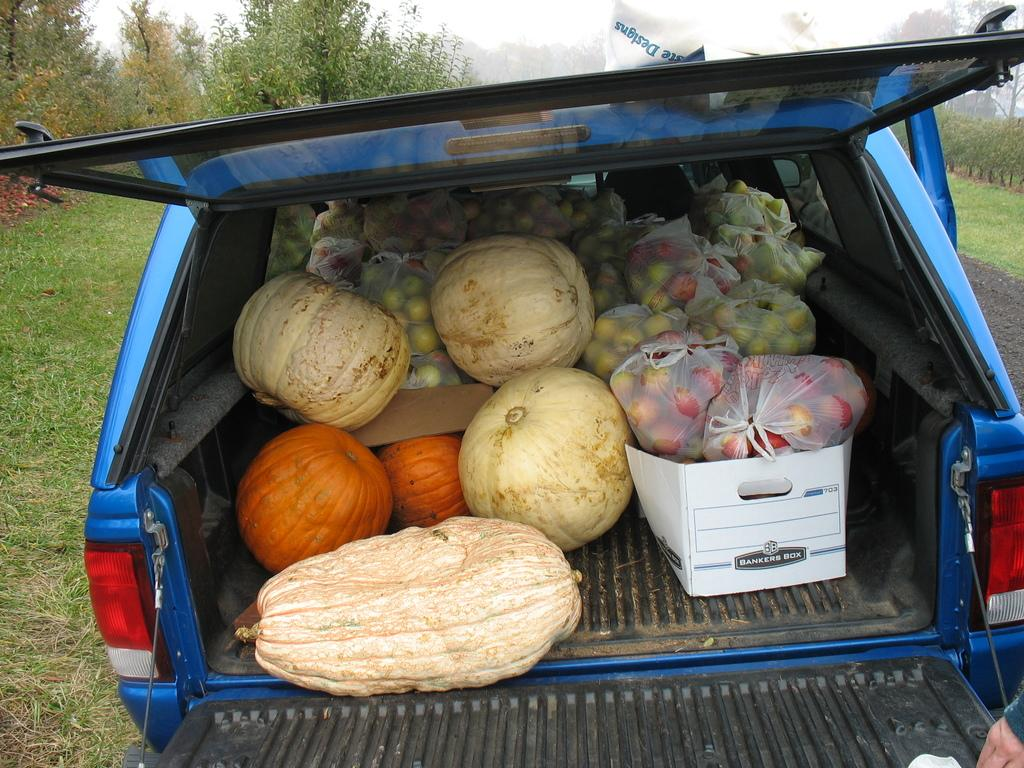What types of food items are visible in the foreground of the image? There are fruits and vegetables in the foreground of the image. How are the fruits and vegetables being transported or stored? The fruits and vegetables are in a car and a box. What type of natural environment can be seen in the background of the image? There is grass, plants, trees, and the sky visible in the background of the image. Can you describe the setting where the image might have been taken? The image might have been taken in a park, given the presence of grass, plants, and trees. What type of shock can be seen affecting the heart of the person in the image? There is no person or heart present in the image; it features fruits and vegetables in a car and a box, with a natural background. 